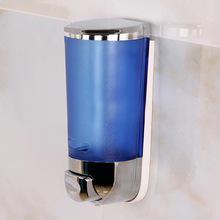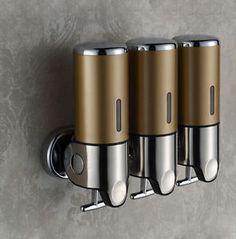The first image is the image on the left, the second image is the image on the right. For the images shown, is this caption "One of the dispensers is brown and silver." true? Answer yes or no. Yes. 